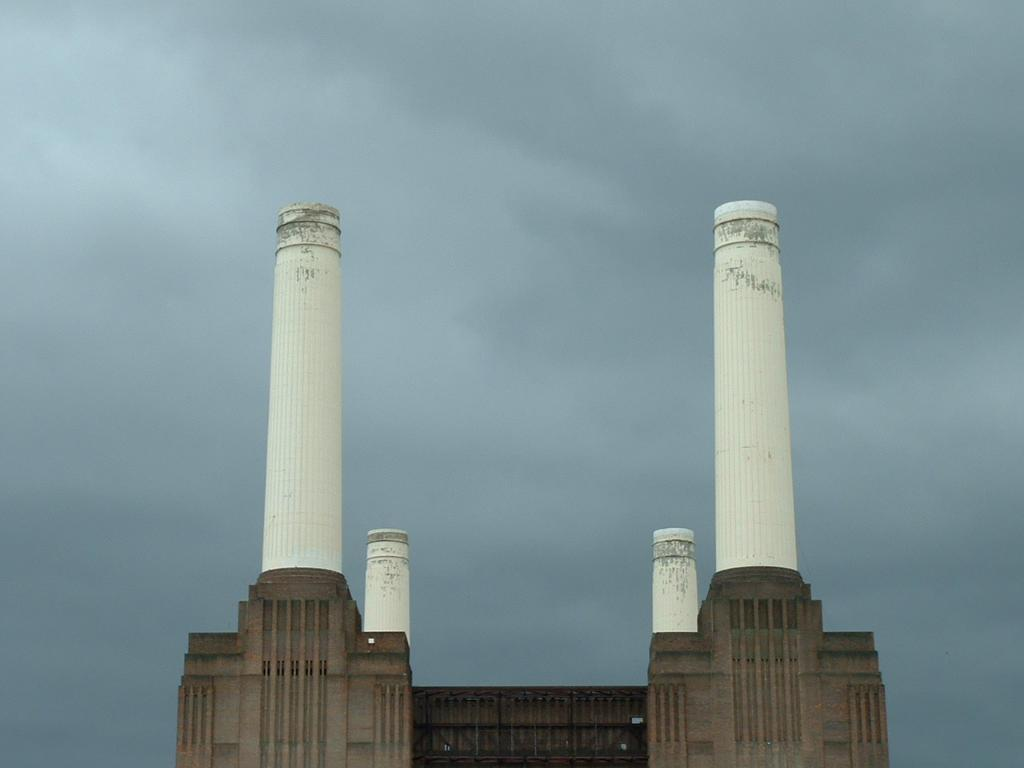What type of architectural feature can be seen in the image? There are pillars in the image. What structures are visible in the image? There are buildings in the image. What part of the natural environment is visible in the image? The sky is visible in the image, and clouds are present in the sky. What type of cart can be seen in the image? There is no cart present in the image. Can you compare the size of the buildings in the image to the size of a nest? There is no nest present in the image, so it cannot be compared to the size of the buildings. 